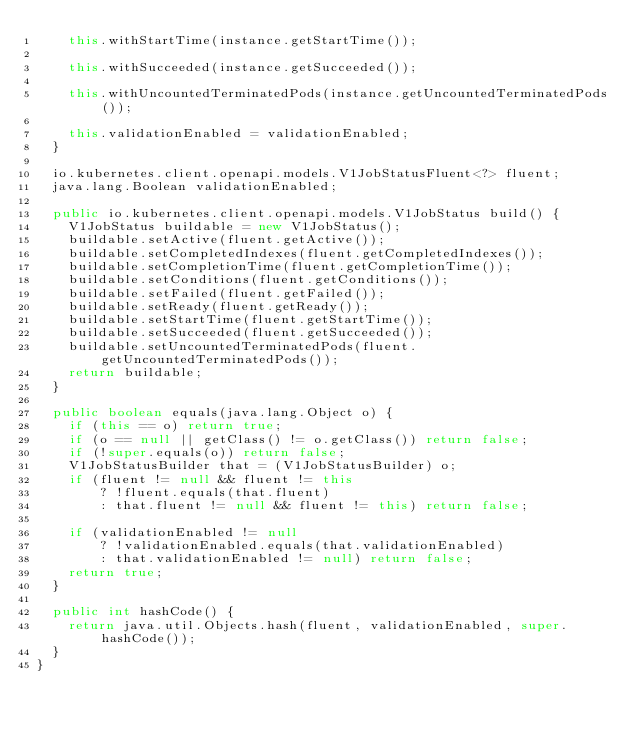<code> <loc_0><loc_0><loc_500><loc_500><_Java_>    this.withStartTime(instance.getStartTime());

    this.withSucceeded(instance.getSucceeded());

    this.withUncountedTerminatedPods(instance.getUncountedTerminatedPods());

    this.validationEnabled = validationEnabled;
  }

  io.kubernetes.client.openapi.models.V1JobStatusFluent<?> fluent;
  java.lang.Boolean validationEnabled;

  public io.kubernetes.client.openapi.models.V1JobStatus build() {
    V1JobStatus buildable = new V1JobStatus();
    buildable.setActive(fluent.getActive());
    buildable.setCompletedIndexes(fluent.getCompletedIndexes());
    buildable.setCompletionTime(fluent.getCompletionTime());
    buildable.setConditions(fluent.getConditions());
    buildable.setFailed(fluent.getFailed());
    buildable.setReady(fluent.getReady());
    buildable.setStartTime(fluent.getStartTime());
    buildable.setSucceeded(fluent.getSucceeded());
    buildable.setUncountedTerminatedPods(fluent.getUncountedTerminatedPods());
    return buildable;
  }

  public boolean equals(java.lang.Object o) {
    if (this == o) return true;
    if (o == null || getClass() != o.getClass()) return false;
    if (!super.equals(o)) return false;
    V1JobStatusBuilder that = (V1JobStatusBuilder) o;
    if (fluent != null && fluent != this
        ? !fluent.equals(that.fluent)
        : that.fluent != null && fluent != this) return false;

    if (validationEnabled != null
        ? !validationEnabled.equals(that.validationEnabled)
        : that.validationEnabled != null) return false;
    return true;
  }

  public int hashCode() {
    return java.util.Objects.hash(fluent, validationEnabled, super.hashCode());
  }
}
</code> 